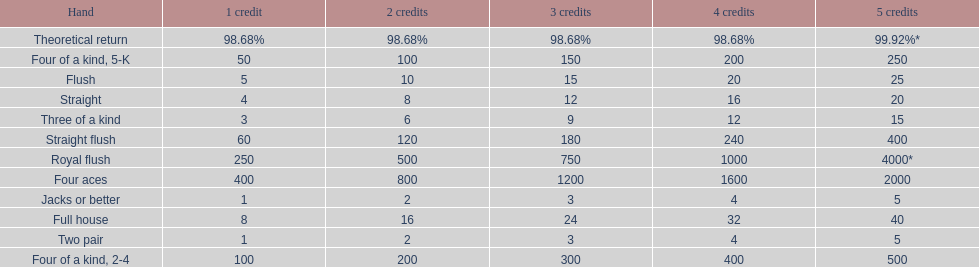Can you parse all the data within this table? {'header': ['Hand', '1 credit', '2 credits', '3 credits', '4 credits', '5 credits'], 'rows': [['Theoretical return', '98.68%', '98.68%', '98.68%', '98.68%', '99.92%*'], ['Four of a kind, 5-K', '50', '100', '150', '200', '250'], ['Flush', '5', '10', '15', '20', '25'], ['Straight', '4', '8', '12', '16', '20'], ['Three of a kind', '3', '6', '9', '12', '15'], ['Straight flush', '60', '120', '180', '240', '400'], ['Royal flush', '250', '500', '750', '1000', '4000*'], ['Four aces', '400', '800', '1200', '1600', '2000'], ['Jacks or better', '1', '2', '3', '4', '5'], ['Full house', '8', '16', '24', '32', '40'], ['Two pair', '1', '2', '3', '4', '5'], ['Four of a kind, 2-4', '100', '200', '300', '400', '500']]} Each four aces win is a multiple of what number? 400. 